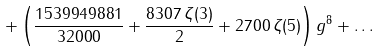<formula> <loc_0><loc_0><loc_500><loc_500>+ \left ( \frac { 1 5 3 9 9 4 9 8 8 1 } { 3 2 0 0 0 } + \frac { 8 3 0 7 \, \zeta ( 3 ) } { 2 } + 2 7 0 0 \, \zeta ( 5 ) \right ) g ^ { 8 } + \dots</formula> 